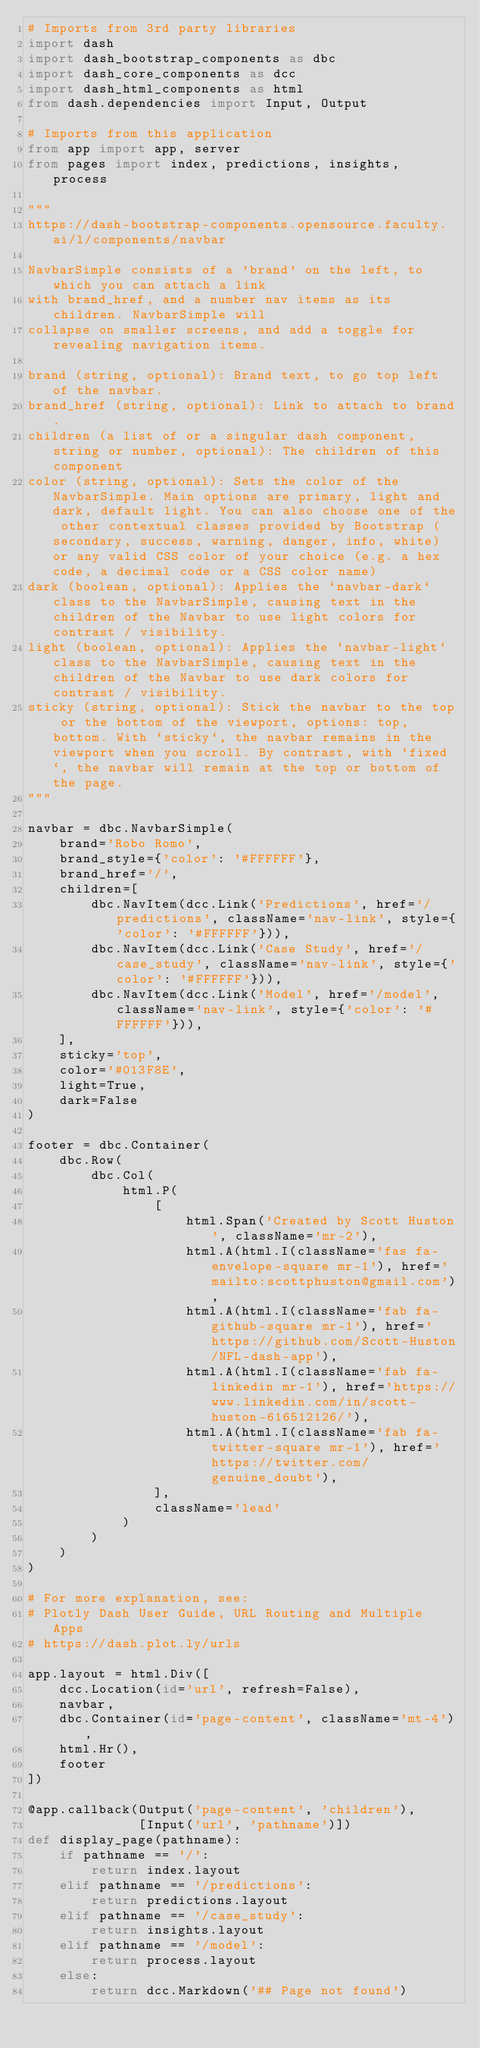<code> <loc_0><loc_0><loc_500><loc_500><_Python_># Imports from 3rd party libraries
import dash
import dash_bootstrap_components as dbc
import dash_core_components as dcc
import dash_html_components as html
from dash.dependencies import Input, Output

# Imports from this application
from app import app, server
from pages import index, predictions, insights, process

"""
https://dash-bootstrap-components.opensource.faculty.ai/l/components/navbar

NavbarSimple consists of a 'brand' on the left, to which you can attach a link 
with brand_href, and a number nav items as its children. NavbarSimple will 
collapse on smaller screens, and add a toggle for revealing navigation items.

brand (string, optional): Brand text, to go top left of the navbar.
brand_href (string, optional): Link to attach to brand.
children (a list of or a singular dash component, string or number, optional): The children of this component
color (string, optional): Sets the color of the NavbarSimple. Main options are primary, light and dark, default light. You can also choose one of the other contextual classes provided by Bootstrap (secondary, success, warning, danger, info, white) or any valid CSS color of your choice (e.g. a hex code, a decimal code or a CSS color name)
dark (boolean, optional): Applies the `navbar-dark` class to the NavbarSimple, causing text in the children of the Navbar to use light colors for contrast / visibility.
light (boolean, optional): Applies the `navbar-light` class to the NavbarSimple, causing text in the children of the Navbar to use dark colors for contrast / visibility.
sticky (string, optional): Stick the navbar to the top or the bottom of the viewport, options: top, bottom. With `sticky`, the navbar remains in the viewport when you scroll. By contrast, with `fixed`, the navbar will remain at the top or bottom of the page.
"""

navbar = dbc.NavbarSimple(
    brand='Robo Romo',
    brand_style={'color': '#FFFFFF'},
    brand_href='/', 
    children=[
        dbc.NavItem(dcc.Link('Predictions', href='/predictions', className='nav-link', style={'color': '#FFFFFF'})), 
        dbc.NavItem(dcc.Link('Case Study', href='/case_study', className='nav-link', style={'color': '#FFFFFF'})), 
        dbc.NavItem(dcc.Link('Model', href='/model', className='nav-link', style={'color': '#FFFFFF'})), 
    ],
    sticky='top',
    color='#013F8E', 
    light=True,
    dark=False
)

footer = dbc.Container(
    dbc.Row(
        dbc.Col(
            html.P(
                [
                    html.Span('Created by Scott Huston', className='mr-2'), 
                    html.A(html.I(className='fas fa-envelope-square mr-1'), href='mailto:scottphuston@gmail.com'),
                    html.A(html.I(className='fab fa-github-square mr-1'), href='https://github.com/Scott-Huston/NFL-dash-app'),
                    html.A(html.I(className='fab fa-linkedin mr-1'), href='https://www.linkedin.com/in/scott-huston-616512126/'),
                    html.A(html.I(className='fab fa-twitter-square mr-1'), href='https://twitter.com/genuine_doubt'),
                ], 
                className='lead'
            )
        )
    )
)

# For more explanation, see: 
# Plotly Dash User Guide, URL Routing and Multiple Apps
# https://dash.plot.ly/urls

app.layout = html.Div([
    dcc.Location(id='url', refresh=False), 
    navbar, 
    dbc.Container(id='page-content', className='mt-4'), 
    html.Hr(), 
    footer
])

@app.callback(Output('page-content', 'children'),
              [Input('url', 'pathname')])
def display_page(pathname):
    if pathname == '/':
        return index.layout
    elif pathname == '/predictions':
        return predictions.layout
    elif pathname == '/case_study':
        return insights.layout
    elif pathname == '/model':
        return process.layout
    else:
        return dcc.Markdown('## Page not found')
</code> 